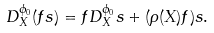Convert formula to latex. <formula><loc_0><loc_0><loc_500><loc_500>D ^ { \phi _ { 0 } } _ { X } ( f s ) = f D ^ { \phi _ { 0 } } _ { X } s + ( \rho ( X ) f ) s .</formula> 